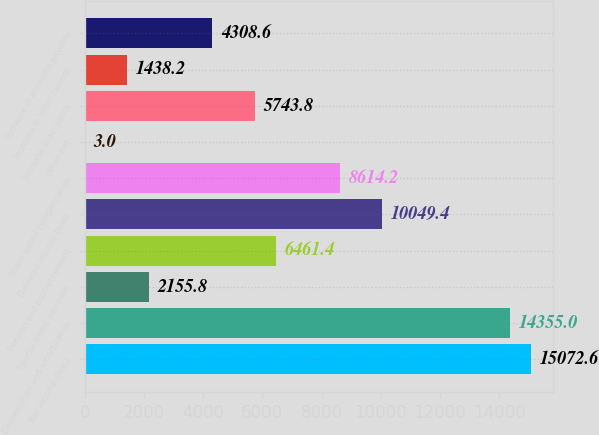<chart> <loc_0><loc_0><loc_500><loc_500><bar_chart><fcel>Net income (loss)<fcel>Depreciation and amortization<fcel>Special items non-cash<fcel>Pension and postretirement<fcel>Deferred income taxes<fcel>Share based compensation<fcel>Other net<fcel>Increase in accounts<fcel>Increase in other current<fcel>Increase in accounts payable<nl><fcel>15072.6<fcel>14355<fcel>2155.8<fcel>6461.4<fcel>10049.4<fcel>8614.2<fcel>3<fcel>5743.8<fcel>1438.2<fcel>4308.6<nl></chart> 